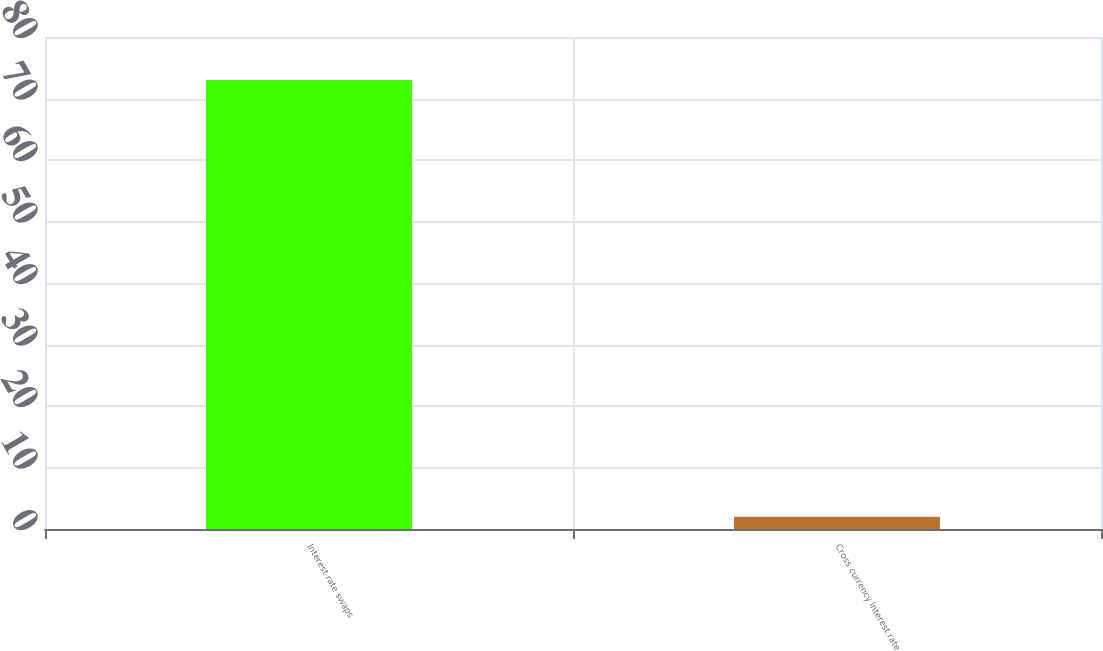Convert chart. <chart><loc_0><loc_0><loc_500><loc_500><bar_chart><fcel>Interest rate swaps<fcel>Cross currency interest rate<nl><fcel>73<fcel>2<nl></chart> 